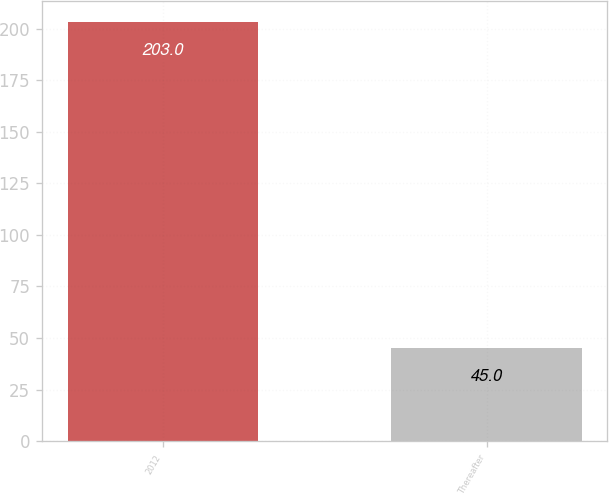Convert chart to OTSL. <chart><loc_0><loc_0><loc_500><loc_500><bar_chart><fcel>2012<fcel>Thereafter<nl><fcel>203<fcel>45<nl></chart> 